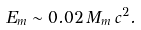Convert formula to latex. <formula><loc_0><loc_0><loc_500><loc_500>E _ { m } \sim 0 . 0 2 \, M _ { m } \, c ^ { 2 } .</formula> 